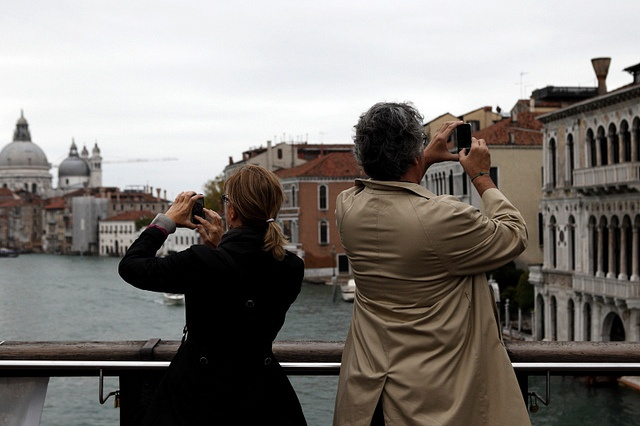Describe the objects in this image and their specific colors. I can see people in white, black, gray, and maroon tones, people in white, black, maroon, gray, and darkgray tones, cell phone in white, black, and gray tones, cell phone in white, black, darkgray, and gray tones, and boat in white, gray, darkgray, lightgray, and black tones in this image. 